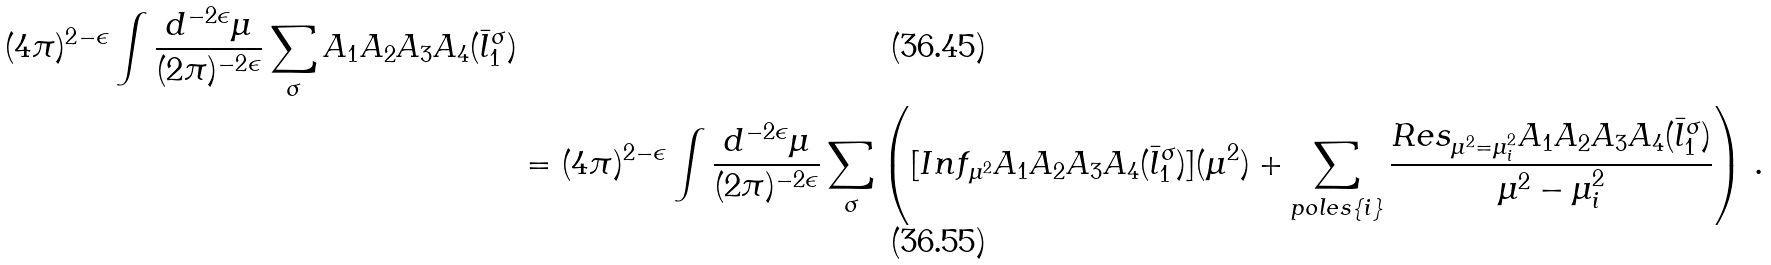<formula> <loc_0><loc_0><loc_500><loc_500>( 4 \pi ) ^ { 2 - \epsilon } \int \frac { d ^ { - 2 \epsilon } \mu } { ( 2 \pi ) ^ { - 2 \epsilon } } \sum _ { \sigma } A _ { 1 } A _ { 2 } A _ { 3 } A _ { 4 } ( \bar { l } _ { 1 } ^ { \sigma } ) \\ & = ( 4 \pi ) ^ { 2 - \epsilon } \int \frac { d ^ { - 2 \epsilon } \mu } { ( 2 \pi ) ^ { - 2 \epsilon } } \sum _ { \sigma } \left ( [ I n f _ { \mu ^ { 2 } } A _ { 1 } A _ { 2 } A _ { 3 } A _ { 4 } ( \bar { l } _ { 1 } ^ { \sigma } ) ] ( \mu ^ { 2 } ) + \sum _ { p o l e s \{ i \} } \frac { R e s _ { \mu ^ { 2 } = \mu _ { i } ^ { 2 } } A _ { 1 } A _ { 2 } A _ { 3 } A _ { 4 } ( \bar { l } _ { 1 } ^ { \sigma } ) } { \mu ^ { 2 } - \mu _ { i } ^ { 2 } } \right ) \, .</formula> 